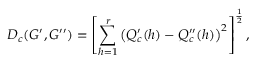<formula> <loc_0><loc_0><loc_500><loc_500>D _ { c } ( G ^ { \prime } , G ^ { \prime \prime } ) = \left [ \sum _ { h = 1 } ^ { r } \left ( Q _ { c } ^ { \prime } ( h ) - Q _ { c } ^ { \prime \prime } ( h ) \right ) ^ { 2 } \right ] ^ { \frac { 1 } { 2 } } ,</formula> 